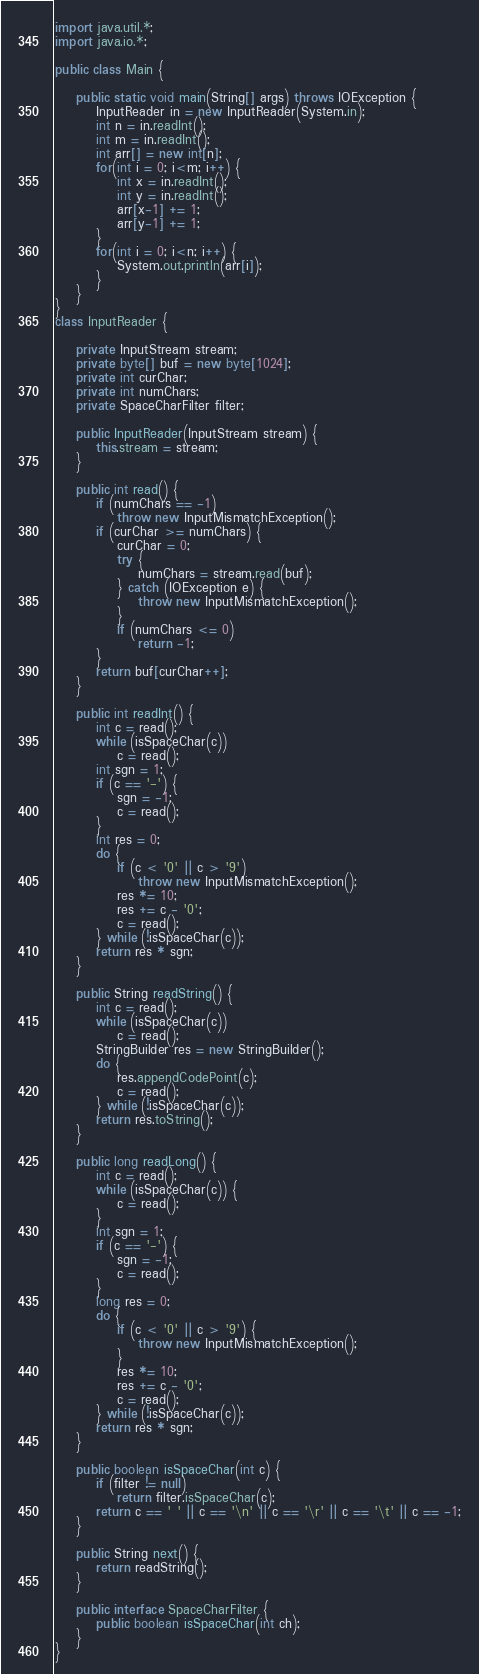<code> <loc_0><loc_0><loc_500><loc_500><_Java_>import java.util.*;
import java.io.*;

public class Main {

	public static void main(String[] args) throws IOException {
		InputReader in = new InputReader(System.in);
		int n = in.readInt();
		int m = in.readInt();
		int arr[] = new int[n]; 
		for(int i = 0; i<m; i++) {
			int x = in.readInt();
			int y = in.readInt();
			arr[x-1] += 1; 
			arr[y-1] += 1;
		}
		for(int i = 0; i<n; i++) {
			System.out.println(arr[i]); 
		}
	}
}
class InputReader {

	private InputStream stream;
	private byte[] buf = new byte[1024];
	private int curChar;
	private int numChars;
	private SpaceCharFilter filter;

	public InputReader(InputStream stream) {
		this.stream = stream;
	}

	public int read() {
		if (numChars == -1)
			throw new InputMismatchException();
		if (curChar >= numChars) {
			curChar = 0;
			try {
				numChars = stream.read(buf);
			} catch (IOException e) {
				throw new InputMismatchException();
			}
			if (numChars <= 0)
				return -1;
		}
		return buf[curChar++];
	}

	public int readInt() {
		int c = read();
		while (isSpaceChar(c))
			c = read();
		int sgn = 1;
		if (c == '-') {
			sgn = -1;
			c = read();
		}
		int res = 0;
		do {
			if (c < '0' || c > '9')
				throw new InputMismatchException();
			res *= 10;
			res += c - '0';
			c = read();
		} while (!isSpaceChar(c));
		return res * sgn;
	}

	public String readString() {
		int c = read();
		while (isSpaceChar(c))
			c = read();
		StringBuilder res = new StringBuilder();
		do {
			res.appendCodePoint(c);
			c = read();
		} while (!isSpaceChar(c));
		return res.toString();
	}

	public long readLong() {
		int c = read();
		while (isSpaceChar(c)) {
			c = read();
		}
		int sgn = 1;
		if (c == '-') {
			sgn = -1;
			c = read();
		}
		long res = 0;
		do {
			if (c < '0' || c > '9') {
				throw new InputMismatchException();
			}
			res *= 10;
			res += c - '0';
			c = read();
		} while (!isSpaceChar(c));
		return res * sgn;
	}
	
	public boolean isSpaceChar(int c) {
		if (filter != null)
			return filter.isSpaceChar(c);
		return c == ' ' || c == '\n' || c == '\r' || c == '\t' || c == -1;
	}

	public String next() {
		return readString();
	}

	public interface SpaceCharFilter {
		public boolean isSpaceChar(int ch);
	}
}

</code> 